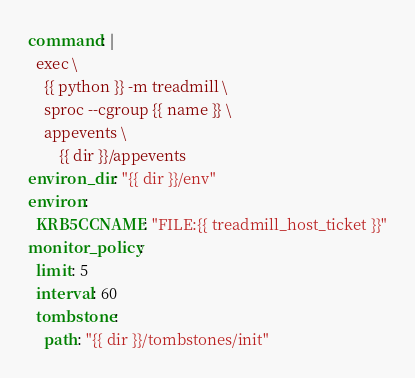Convert code to text. <code><loc_0><loc_0><loc_500><loc_500><_YAML_>command: |
  exec \
    {{ python }} -m treadmill \
    sproc --cgroup {{ name }} \
    appevents \
        {{ dir }}/appevents
environ_dir: "{{ dir }}/env"
environ:
  KRB5CCNAME: "FILE:{{ treadmill_host_ticket }}"
monitor_policy:
  limit: 5
  interval: 60
  tombstone:
    path: "{{ dir }}/tombstones/init"
</code> 